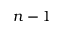<formula> <loc_0><loc_0><loc_500><loc_500>n - 1</formula> 